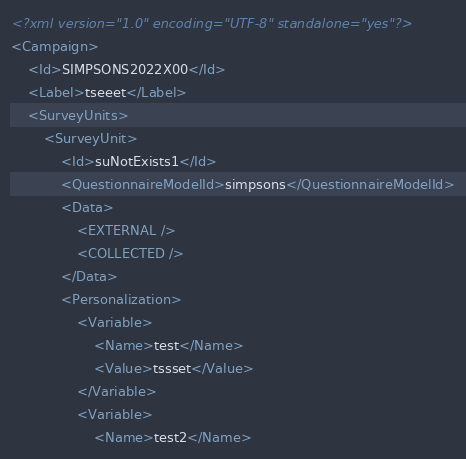<code> <loc_0><loc_0><loc_500><loc_500><_XML_><?xml version="1.0" encoding="UTF-8" standalone="yes"?>
<Campaign>
	<Id>SIMPSONS2022X00</Id>
	<Label>tseeet</Label>
	<SurveyUnits>
		<SurveyUnit>
			<Id>suNotExists1</Id>
			<QuestionnaireModelId>simpsons</QuestionnaireModelId>
			<Data>
				<EXTERNAL />
				<COLLECTED />
			</Data>
			<Personalization>
				<Variable>
					<Name>test</Name>
					<Value>tssset</Value>
				</Variable>
				<Variable>
					<Name>test2</Name></code> 